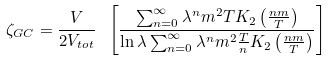<formula> <loc_0><loc_0><loc_500><loc_500>\zeta _ { G C } = \frac { V } { 2 V _ { t o t } } \ \left [ \frac { \sum _ { n = 0 } ^ { \infty } \lambda ^ { n } m ^ { 2 } T K _ { 2 } \left ( \frac { n m } { T } \right ) } { \ln \lambda \sum _ { n = 0 } ^ { \infty } \lambda ^ { n } m ^ { 2 } \frac { T } { n } K _ { 2 } \left ( \frac { n m } { T } \right ) } \right ]</formula> 